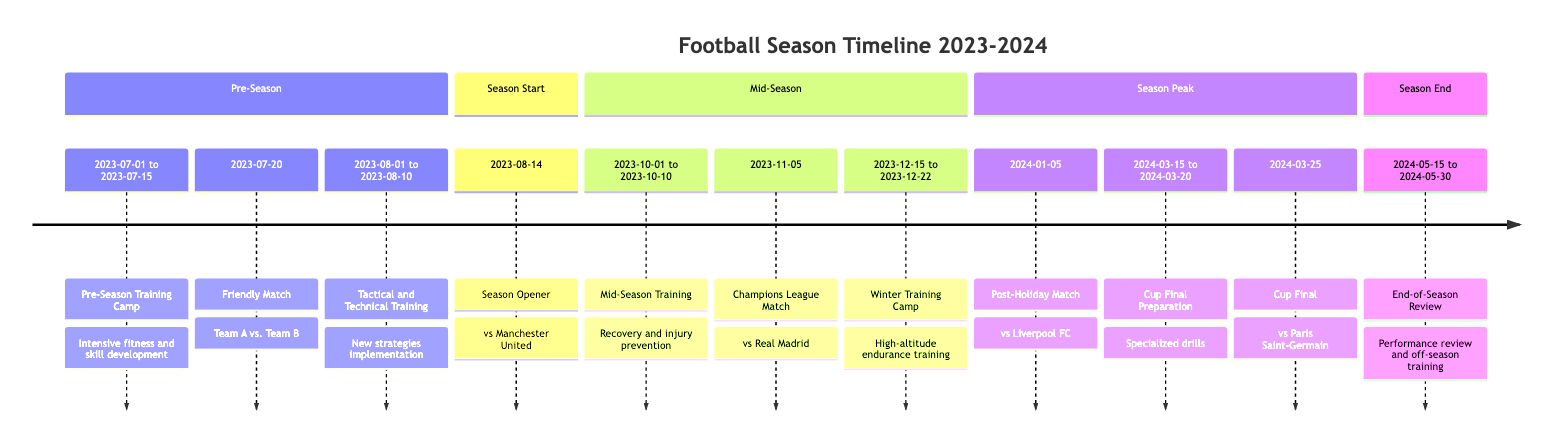What event starts the football timeline? The first event listed in the timeline is "Pre-Season Training Camp," which begins on July 1, 2023.
Answer: Pre-Season Training Camp How long does the Mid-Season Training last? The Mid-Season Training spans from October 1, 2023, to October 10, 2023, making it a duration of 10 days.
Answer: 10 days Which match is scheduled immediately after the Winter Training Camp? The Winter Training Camp ends on December 22, 2023, followed immediately by the Post-Holiday Match on January 5, 2024.
Answer: Post-Holiday Match What is the date of the Champions League Group Stage Match? The specific date for the Champions League Group Stage Match is mentioned as November 5, 2023.
Answer: 2023-11-05 How many events are scheduled before the Cup Final? The timeline lists a total of five events before the Cup Final, culminating with the Cup Final Preparation.
Answer: 5 events Which training session focuses on recovery and injury prevention? The training dedicated to recovery and injury prevention is the Mid-Season Training held from October 1 to October 10, 2023.
Answer: Mid-Season Training What is the purpose of the Cup Final Preparation? The Cup Final Preparation is designed for specialized drills and match simulation at La Masia Academy, gearing up for the upcoming Cup Final.
Answer: Specialized drills When is the End-of-Season Review and Training scheduled to begin? The schedule indicates that the End-of-Season Review and Training commences on May 15, 2024.
Answer: 2024-05-15 Which match follows the Season Opener? The match that occurs following the Season Opener against Manchester United is the Mid-Season Training event, occurring in October.
Answer: Mid-Season Training 